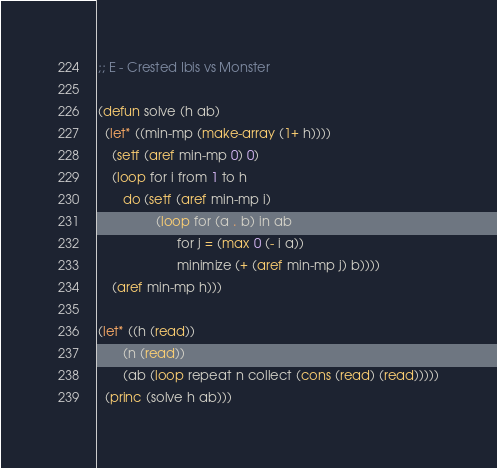Convert code to text. <code><loc_0><loc_0><loc_500><loc_500><_Lisp_>;; E - Crested Ibis vs Monster

(defun solve (h ab)
  (let* ((min-mp (make-array (1+ h))))
    (setf (aref min-mp 0) 0)
    (loop for i from 1 to h
       do (setf (aref min-mp i)
                (loop for (a . b) in ab
                      for j = (max 0 (- i a))
                      minimize (+ (aref min-mp j) b))))
    (aref min-mp h)))

(let* ((h (read))
       (n (read))
       (ab (loop repeat n collect (cons (read) (read)))))
  (princ (solve h ab)))
</code> 